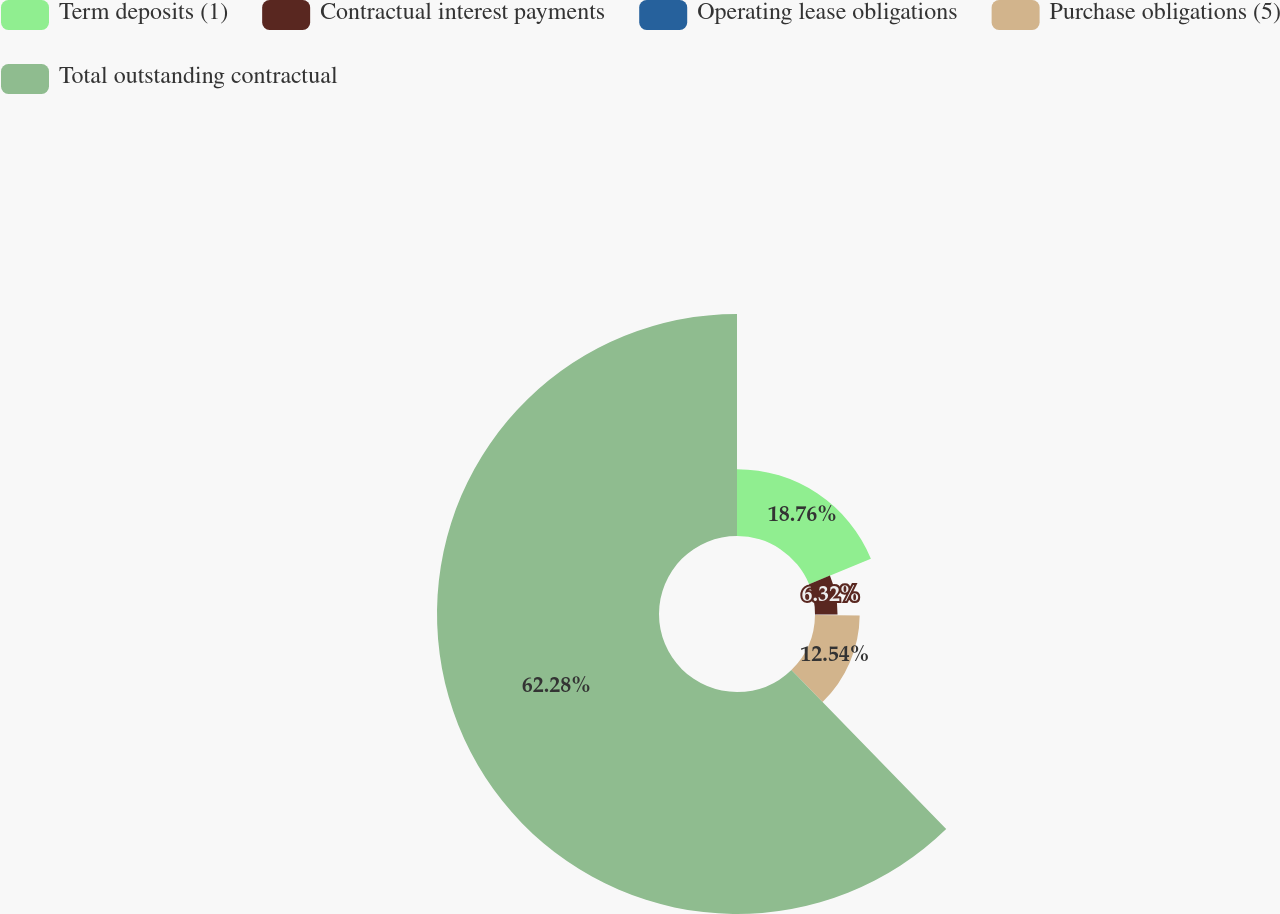Convert chart to OTSL. <chart><loc_0><loc_0><loc_500><loc_500><pie_chart><fcel>Term deposits (1)<fcel>Contractual interest payments<fcel>Operating lease obligations<fcel>Purchase obligations (5)<fcel>Total outstanding contractual<nl><fcel>18.76%<fcel>6.32%<fcel>0.1%<fcel>12.54%<fcel>62.28%<nl></chart> 